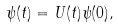Convert formula to latex. <formula><loc_0><loc_0><loc_500><loc_500>\psi ( t ) = U ( t ) \psi ( 0 ) ,</formula> 